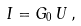<formula> <loc_0><loc_0><loc_500><loc_500>I = G _ { 0 } \, U \, ,</formula> 